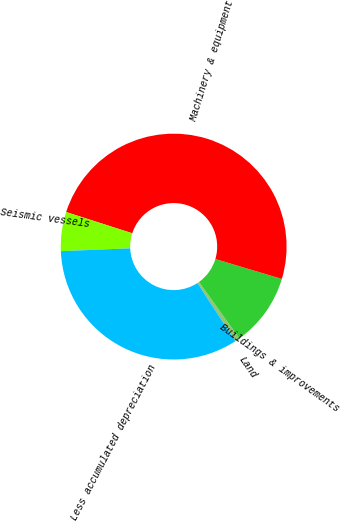<chart> <loc_0><loc_0><loc_500><loc_500><pie_chart><fcel>Land<fcel>Buildings & improvements<fcel>Machinery & equipment<fcel>Seismic vessels<fcel>Less accumulated depreciation<nl><fcel>0.69%<fcel>10.49%<fcel>49.68%<fcel>5.59%<fcel>33.55%<nl></chart> 